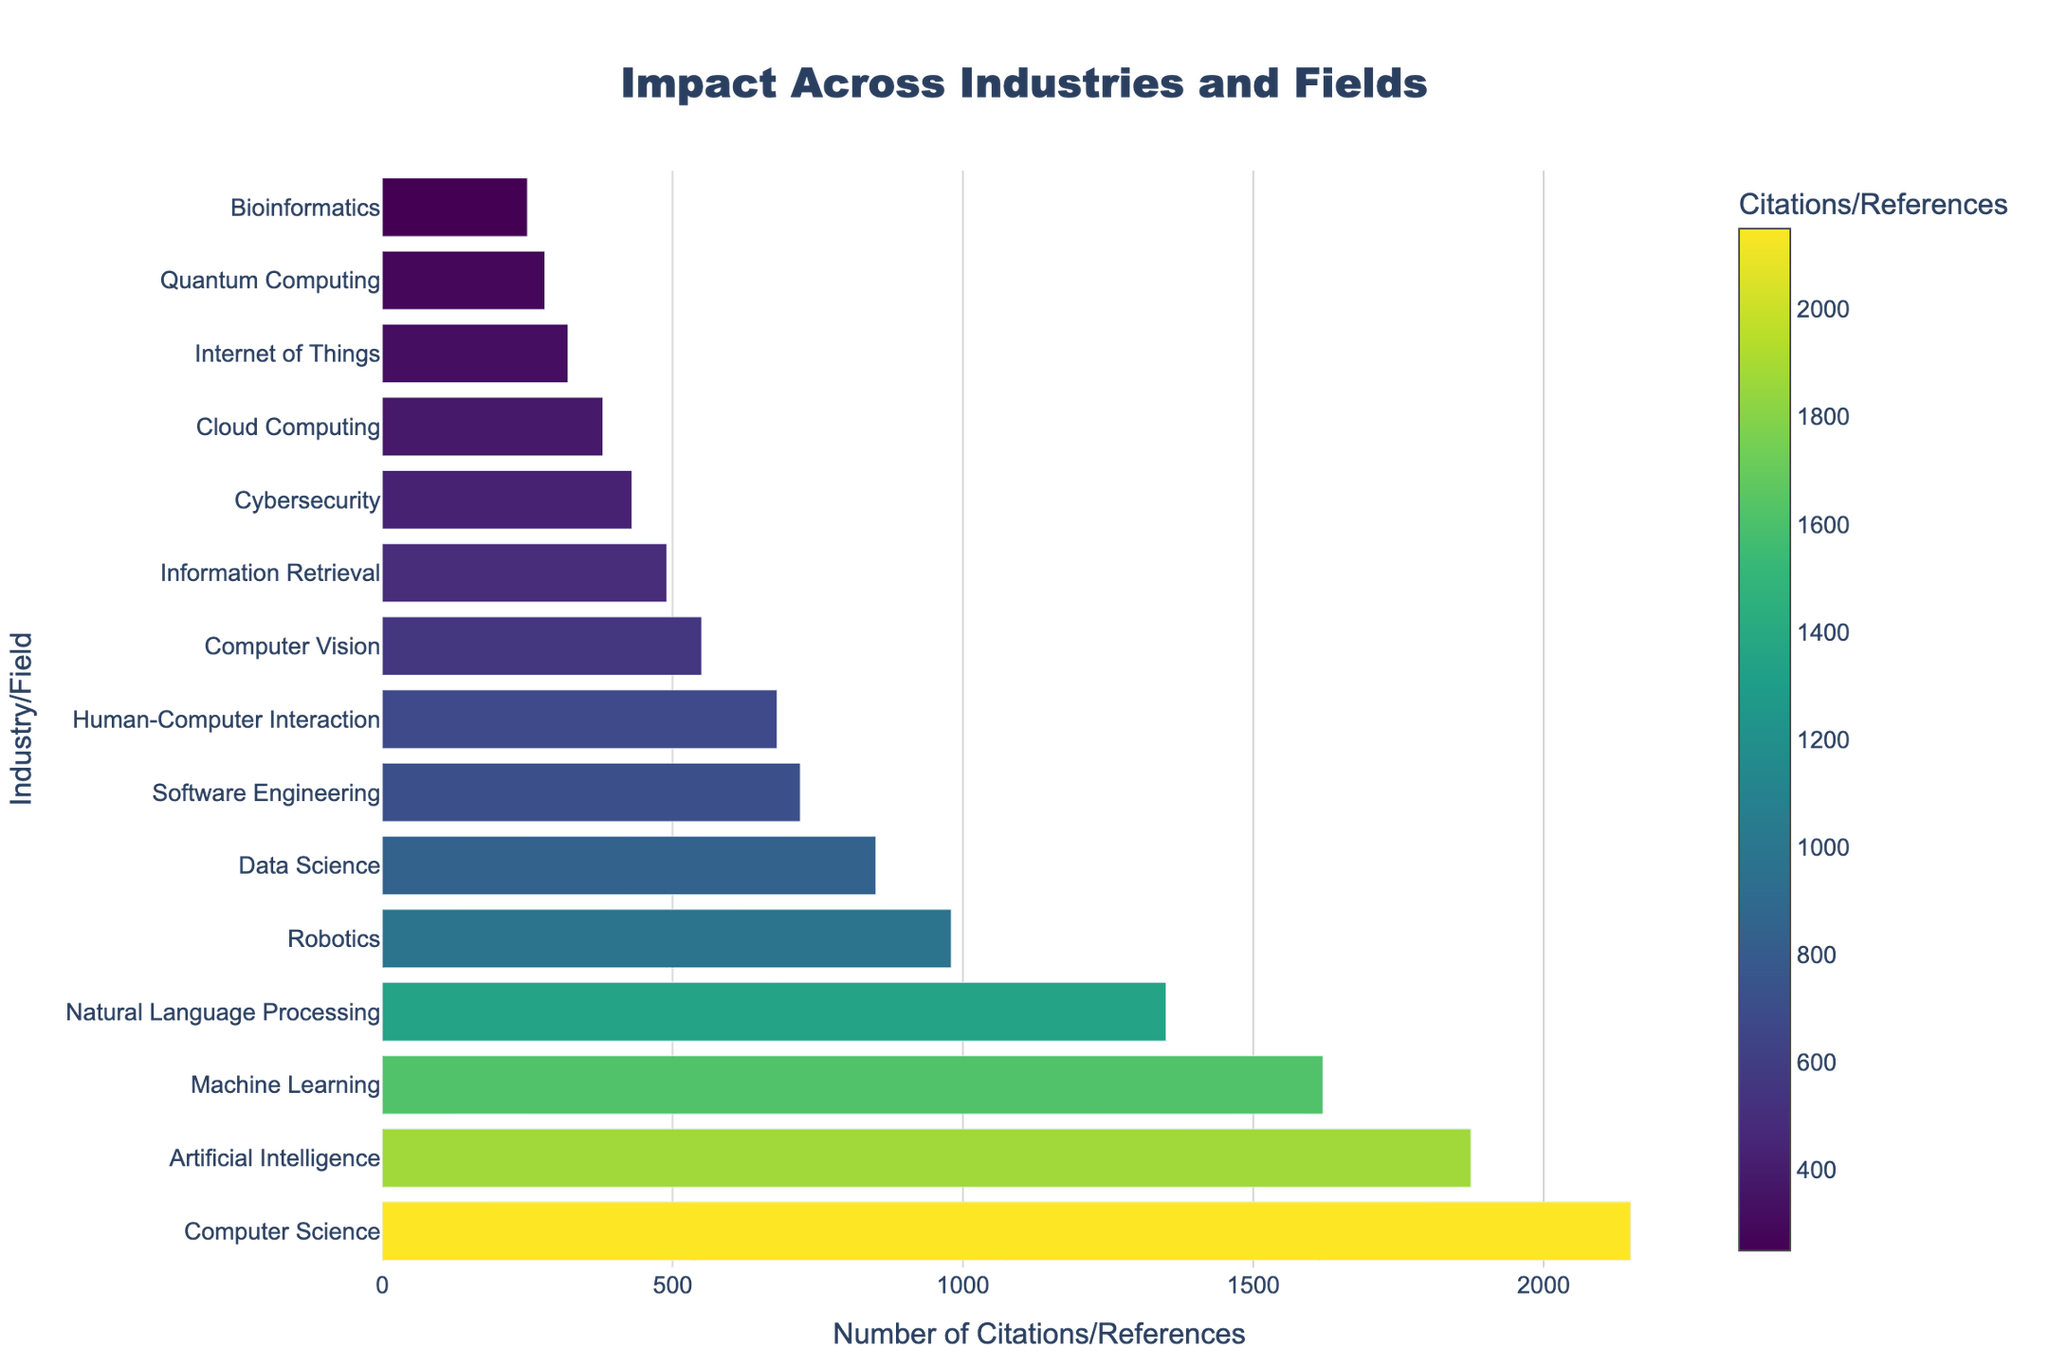Which industry/field has the highest number of citations/references? By looking at the chart, the bar representing Computer Science is the longest, indicating it has the highest number of citations/references.
Answer: Computer Science Compare the impact between Computer Vision and Cybersecurity. Which one has more citations/references? The bar for Computer Vision is longer than the bar for Cybersecurity, showing that Computer Vision has more citations/references.
Answer: Computer Vision What's the sum of citations/references for Robotics and Data Science? Based on the chart, Robotics has 980 citations/references and Data Science has 850. Adding these together, we get 980 + 850 = 1830.
Answer: 1830 How many more citations/references does Machine Learning have compared to Cloud Computing? Machine Learning has 1620 citations/references, and Cloud Computing has 380. The difference is 1620 - 380 = 1240.
Answer: 1240 What is the average number of citations/references for the fields of Artificial Intelligence, Natural Language Processing, and Quantum Computing? The citations/references are 1875 for Artificial Intelligence, 1350 for Natural Language Processing, and 280 for Quantum Computing. The average is (1875 + 1350 + 280) / 3 = 3505 / 3 ≈ 1168.33.
Answer: 1168.33 Rank the top three industries/fields in terms of citations/references. Observing the figure, the top three longest bars represent Computer Science, Artificial Intelligence, and Machine Learning in that order.
Answer: Computer Science, Artificial Intelligence, Machine Learning What is the difference in citations/references between the most and least cited fields? The most cited field is Computer Science with 2150 citations, and the least cited is Bioinformatics with 250 citations. The difference is 2150 - 250 = 1900.
Answer: 1900 What percentage of the total citations/references does Natural Language Processing contribute? Summing all citations/references: 2150 + 1875 + 1620 + 1350 + 980 + 850 + 720 + 680 + 550 + 490 + 430 + 380 + 320 + 280 + 250 = 13925. Natural Language Processing contributes (1350 / 13925) × 100 ≈ 9.69%.
Answer: 9.69% How visually distinguishable are the citations/references between Data Science and Human-Computer Interaction based on bar length? The bar for Data Science is slightly longer than the bar for Human-Computer Interaction, indicating that Data Science has more citations/references.
Answer: Data Science Of the fields listed, which have fewer than 500 citations/references? Fields with shorter bars and fewer than 500 citations/references are Information Retrieval (490), Cybersecurity (430), Cloud Computing (380), Internet of Things (320), Quantum Computing (280), and Bioinformatics (250).
Answer: Information Retrieval, Cybersecurity, Cloud Computing, Internet of Things, Quantum Computing, Bioinformatics 